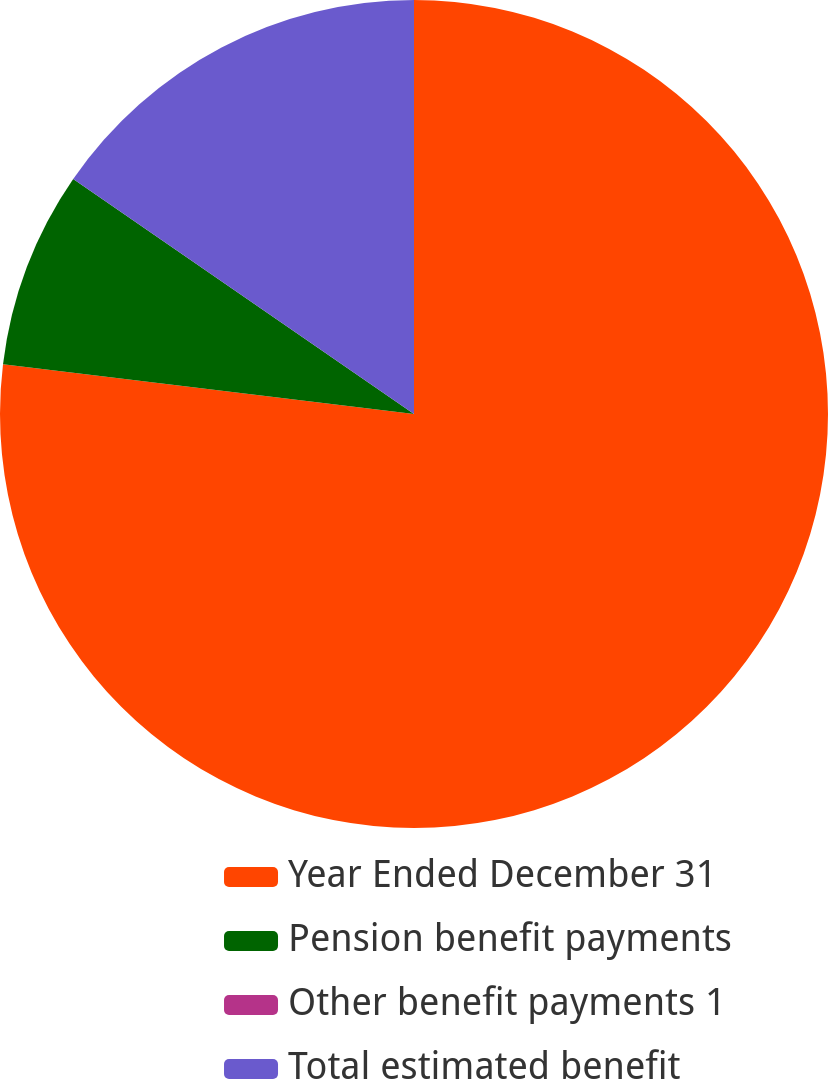Convert chart to OTSL. <chart><loc_0><loc_0><loc_500><loc_500><pie_chart><fcel>Year Ended December 31<fcel>Pension benefit payments<fcel>Other benefit payments 1<fcel>Total estimated benefit<nl><fcel>76.92%<fcel>7.69%<fcel>0.0%<fcel>15.39%<nl></chart> 